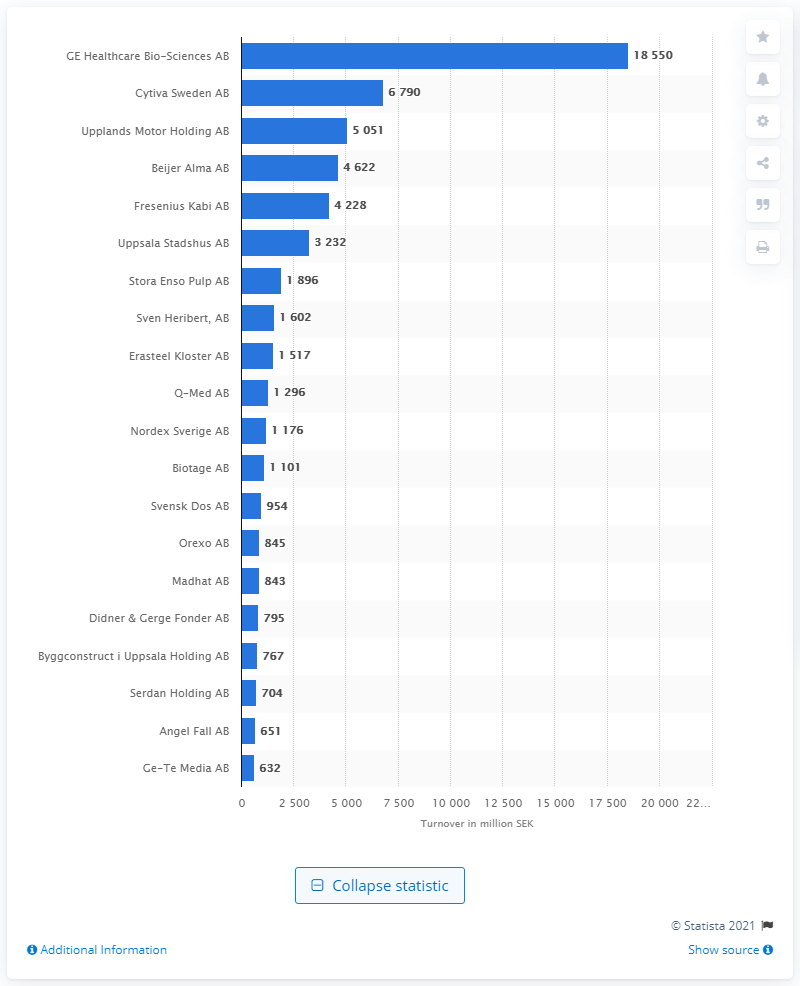Mention a couple of crucial points in this snapshot. The turnover of Cytiva Sweden AB was 6,790.. In February 2021, GE Healthcare Bio-Sciences AB had the highest turnover among companies in Uppsala, according to records. According to the information available, Cytiva Sweden AB was ranked second in terms of turnover in 2021. 